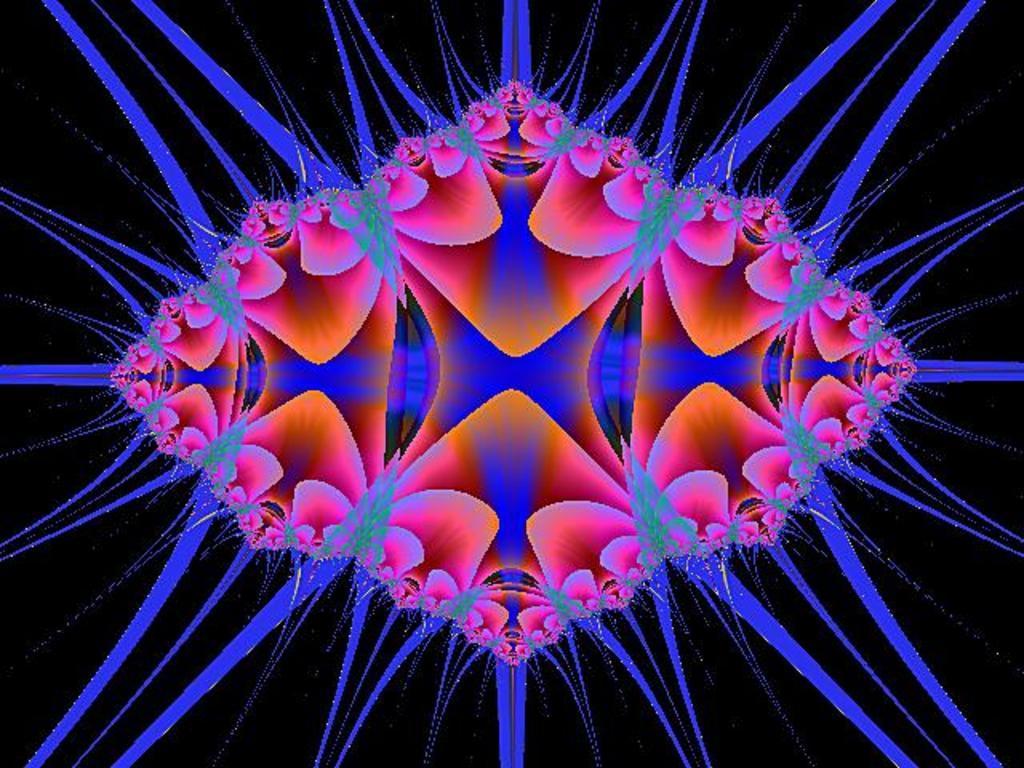Can you describe this image briefly? In this image, it seems like an animated design. 